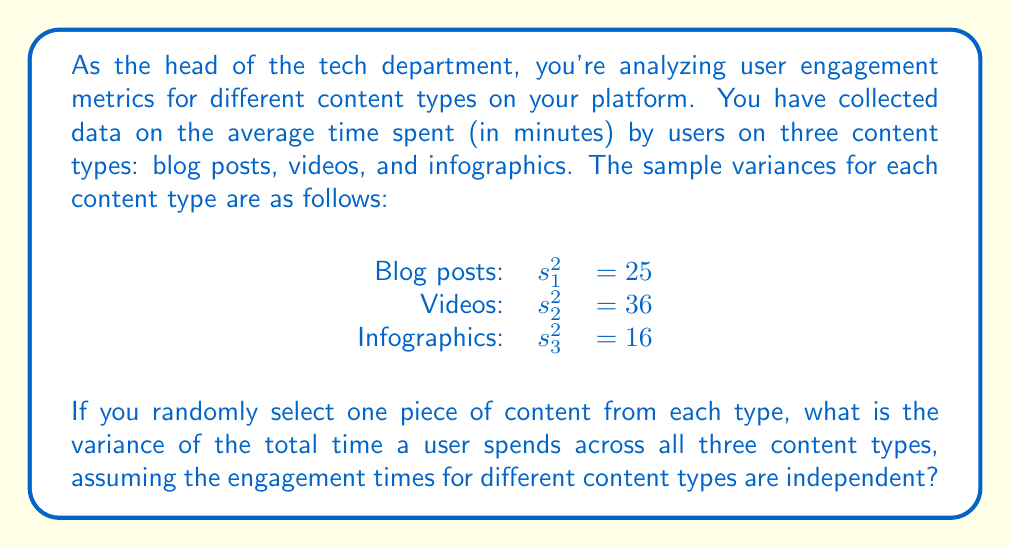Show me your answer to this math problem. To solve this problem, we need to use the properties of variance for independent random variables. The key property we'll use is that the variance of a sum of independent random variables is equal to the sum of their individual variances.

Let's approach this step-by-step:

1) Let $X_1$, $X_2$, and $X_3$ represent the time spent on blog posts, videos, and infographics respectively.

2) We're interested in the total time spent, which is $T = X_1 + X_2 + X_3$.

3) Given that the content types are independent, we can use the property:

   $Var(T) = Var(X_1 + X_2 + X_3) = Var(X_1) + Var(X_2) + Var(X_3)$

4) We're given sample variances, but for a single randomly selected piece of content, these sample variances are our best estimates of the population variances. So we can use them directly:

   $Var(X_1) = s_1^2 = 25$
   $Var(X_2) = s_2^2 = 36$
   $Var(X_3) = s_3^2 = 16$

5) Now, we can simply sum these variances:

   $Var(T) = 25 + 36 + 16 = 77$

Therefore, the variance of the total time a user spends across all three content types is 77 square minutes.
Answer: $77$ square minutes 